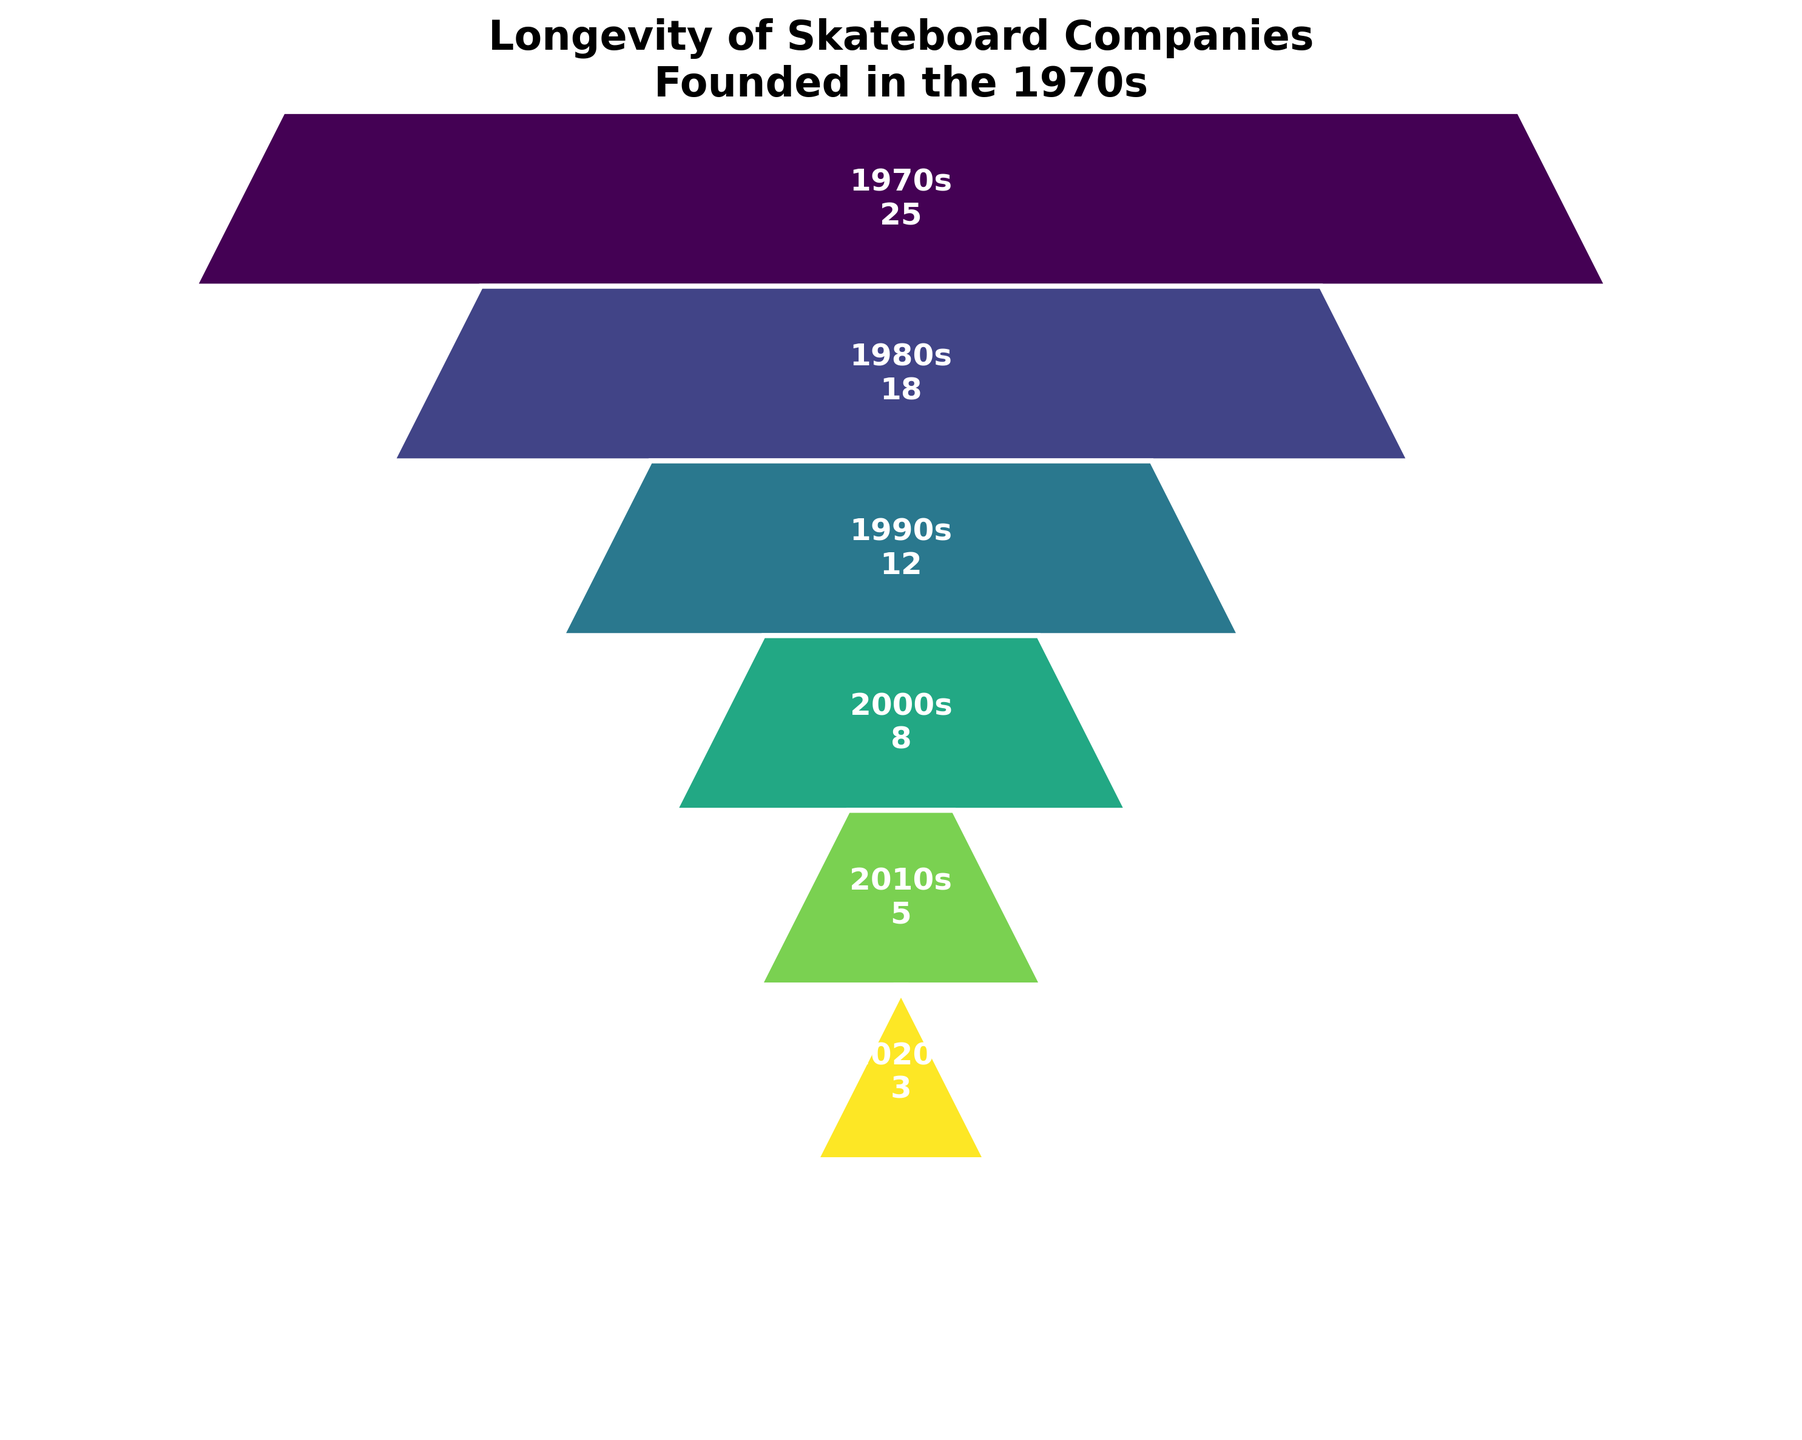What is the title of the figure? The title is displayed at the top of the figure and summarizes the main focus of the chart.
Answer: Longevity of Skateboard Companies Founded in the 1970s How many skateboard companies that were founded in the 1970s still survived in the 2020s? The figure shows a funnel with various segments representing different decades. The number of companies surviving in the 2020s is shown in the lowest segment.
Answer: 3 In which decade did the number of surviving skateboard companies drop the most? By comparing the number of surviving companies in each subsequent decade, the largest decrease can be observed between two decades.
Answer: From the 1970s to the 1980s What color scheme is used in the figure, and what might it represent? The funnel sections use different shades derived from a continuous colormap (viridis), which often represents a gradient of values.
Answer: A gradient from purple to yellow How many skateboard companies survived into the 2000s? The number of companies surviving in each decade is depicted textually within each funnel segment. Look at the section labeled 2000s.
Answer: 8 Calculate the percentage reduction in the number of surviving companies from the 1990s to the 2000s. Subtract the number of companies in the 2000s (8) from those in the 1990s (12), then divide by the number in the 1990s (12), and multiply by 100 for the percentage.
Answer: 33.3% Which decade shows the smallest decrease in the number of surviving skateboard companies compared to the previous decade? By comparing the reduction in numbers from each decade to the next, identify which had the smallest drop.
Answer: From the 1980s to the 1990s How does the width of the segments change across the funnel chart, and what does this signify? The segment widths decrease from top to bottom, indicating a reduction in the number of surviving companies each subsequent decade.
Answer: Narrower segments indicate fewer surviving companies What is the difference between the number of surviving companies in the 1980s and the 2010s? Subtract the number of companies in the 2010s (5) from the number in the 1980s (18).
Answer: 13 How many decades are represented in the funnel chart? Count the distinct segments or labels indicating different decades shown in the funnel chart.
Answer: 6 